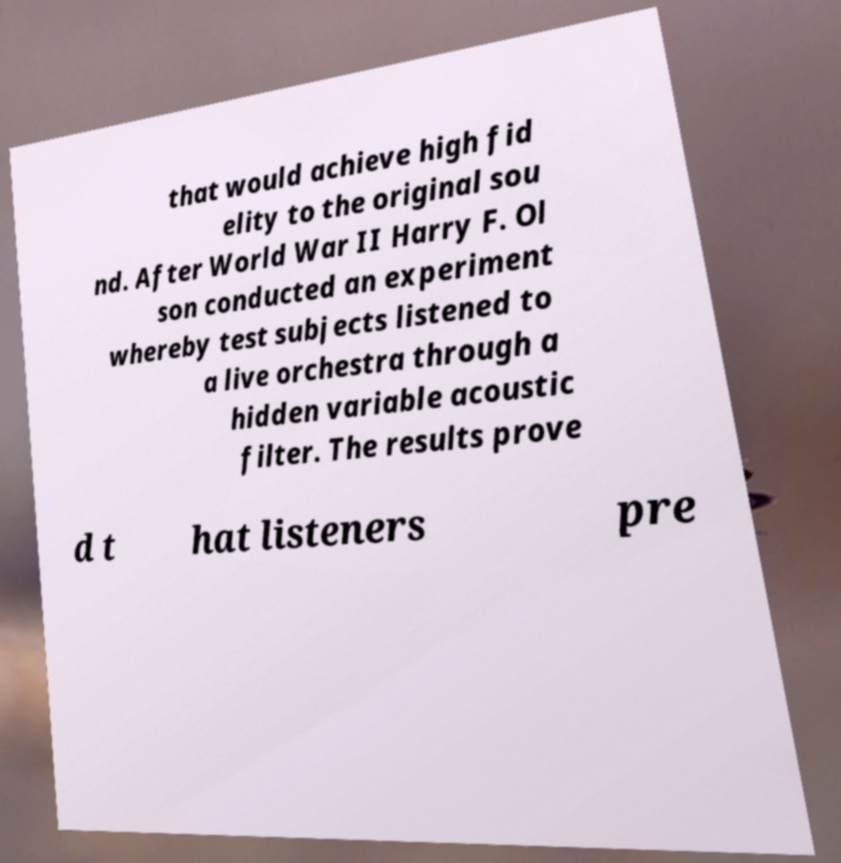Please identify and transcribe the text found in this image. that would achieve high fid elity to the original sou nd. After World War II Harry F. Ol son conducted an experiment whereby test subjects listened to a live orchestra through a hidden variable acoustic filter. The results prove d t hat listeners pre 